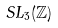<formula> <loc_0><loc_0><loc_500><loc_500>S L _ { 3 } ( \mathbb { Z } )</formula> 